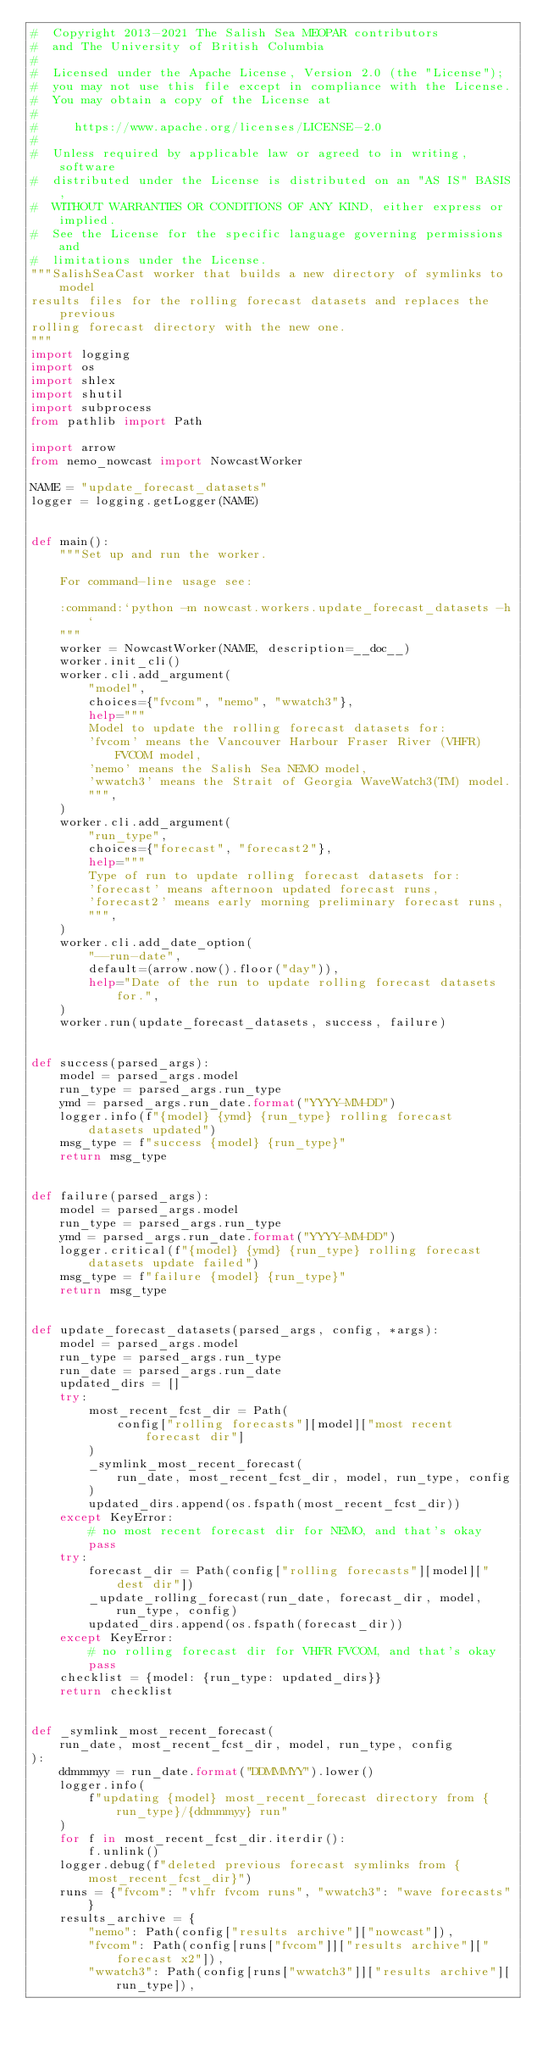<code> <loc_0><loc_0><loc_500><loc_500><_Python_>#  Copyright 2013-2021 The Salish Sea MEOPAR contributors
#  and The University of British Columbia
#
#  Licensed under the Apache License, Version 2.0 (the "License");
#  you may not use this file except in compliance with the License.
#  You may obtain a copy of the License at
#
#     https://www.apache.org/licenses/LICENSE-2.0
#
#  Unless required by applicable law or agreed to in writing, software
#  distributed under the License is distributed on an "AS IS" BASIS,
#  WITHOUT WARRANTIES OR CONDITIONS OF ANY KIND, either express or implied.
#  See the License for the specific language governing permissions and
#  limitations under the License.
"""SalishSeaCast worker that builds a new directory of symlinks to model
results files for the rolling forecast datasets and replaces the previous
rolling forecast directory with the new one.
"""
import logging
import os
import shlex
import shutil
import subprocess
from pathlib import Path

import arrow
from nemo_nowcast import NowcastWorker

NAME = "update_forecast_datasets"
logger = logging.getLogger(NAME)


def main():
    """Set up and run the worker.

    For command-line usage see:

    :command:`python -m nowcast.workers.update_forecast_datasets -h`
    """
    worker = NowcastWorker(NAME, description=__doc__)
    worker.init_cli()
    worker.cli.add_argument(
        "model",
        choices={"fvcom", "nemo", "wwatch3"},
        help="""
        Model to update the rolling forecast datasets for:
        'fvcom' means the Vancouver Harbour Fraser River (VHFR) FVCOM model,
        'nemo' means the Salish Sea NEMO model,
        'wwatch3' means the Strait of Georgia WaveWatch3(TM) model.
        """,
    )
    worker.cli.add_argument(
        "run_type",
        choices={"forecast", "forecast2"},
        help="""
        Type of run to update rolling forecast datasets for:
        'forecast' means afternoon updated forecast runs,
        'forecast2' means early morning preliminary forecast runs,
        """,
    )
    worker.cli.add_date_option(
        "--run-date",
        default=(arrow.now().floor("day")),
        help="Date of the run to update rolling forecast datasets for.",
    )
    worker.run(update_forecast_datasets, success, failure)


def success(parsed_args):
    model = parsed_args.model
    run_type = parsed_args.run_type
    ymd = parsed_args.run_date.format("YYYY-MM-DD")
    logger.info(f"{model} {ymd} {run_type} rolling forecast datasets updated")
    msg_type = f"success {model} {run_type}"
    return msg_type


def failure(parsed_args):
    model = parsed_args.model
    run_type = parsed_args.run_type
    ymd = parsed_args.run_date.format("YYYY-MM-DD")
    logger.critical(f"{model} {ymd} {run_type} rolling forecast datasets update failed")
    msg_type = f"failure {model} {run_type}"
    return msg_type


def update_forecast_datasets(parsed_args, config, *args):
    model = parsed_args.model
    run_type = parsed_args.run_type
    run_date = parsed_args.run_date
    updated_dirs = []
    try:
        most_recent_fcst_dir = Path(
            config["rolling forecasts"][model]["most recent forecast dir"]
        )
        _symlink_most_recent_forecast(
            run_date, most_recent_fcst_dir, model, run_type, config
        )
        updated_dirs.append(os.fspath(most_recent_fcst_dir))
    except KeyError:
        # no most recent forecast dir for NEMO, and that's okay
        pass
    try:
        forecast_dir = Path(config["rolling forecasts"][model]["dest dir"])
        _update_rolling_forecast(run_date, forecast_dir, model, run_type, config)
        updated_dirs.append(os.fspath(forecast_dir))
    except KeyError:
        # no rolling forecast dir for VHFR FVCOM, and that's okay
        pass
    checklist = {model: {run_type: updated_dirs}}
    return checklist


def _symlink_most_recent_forecast(
    run_date, most_recent_fcst_dir, model, run_type, config
):
    ddmmmyy = run_date.format("DDMMMYY").lower()
    logger.info(
        f"updating {model} most_recent_forecast directory from {run_type}/{ddmmmyy} run"
    )
    for f in most_recent_fcst_dir.iterdir():
        f.unlink()
    logger.debug(f"deleted previous forecast symlinks from {most_recent_fcst_dir}")
    runs = {"fvcom": "vhfr fvcom runs", "wwatch3": "wave forecasts"}
    results_archive = {
        "nemo": Path(config["results archive"]["nowcast"]),
        "fvcom": Path(config[runs["fvcom"]]["results archive"]["forecast x2"]),
        "wwatch3": Path(config[runs["wwatch3"]]["results archive"][run_type]),</code> 